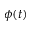Convert formula to latex. <formula><loc_0><loc_0><loc_500><loc_500>\phi ( t )</formula> 